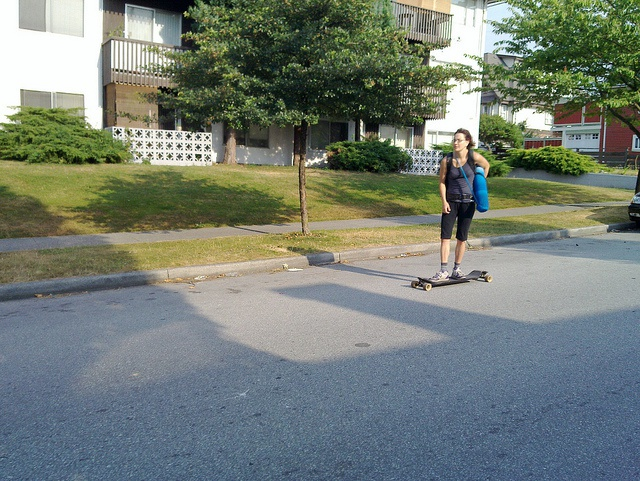Describe the objects in this image and their specific colors. I can see people in white, black, gray, and tan tones, skateboard in white, gray, black, darkgray, and tan tones, and car in white, black, gray, and darkgray tones in this image. 